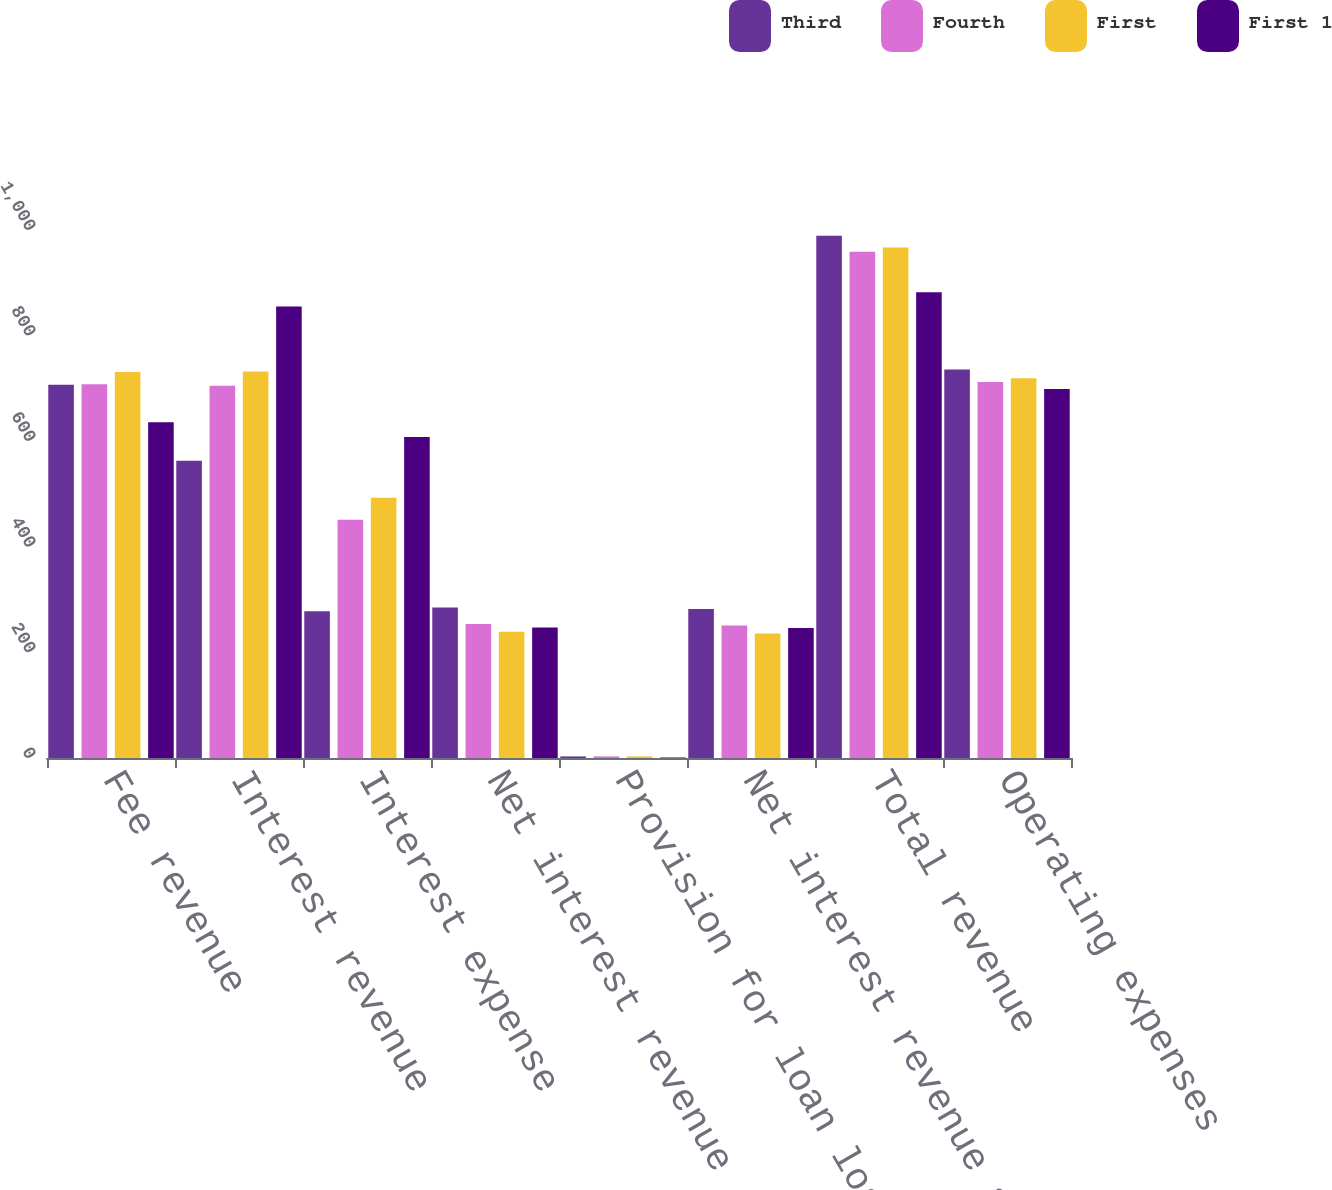<chart> <loc_0><loc_0><loc_500><loc_500><stacked_bar_chart><ecel><fcel>Fee revenue<fcel>Interest revenue<fcel>Interest expense<fcel>Net interest revenue<fcel>Provision for loan losses<fcel>Net interest revenue after<fcel>Total revenue<fcel>Operating expenses<nl><fcel>Third<fcel>707<fcel>563<fcel>278<fcel>285<fcel>3<fcel>282<fcel>989<fcel>736<nl><fcel>Fourth<fcel>708<fcel>705<fcel>451<fcel>254<fcel>3<fcel>251<fcel>959<fcel>712<nl><fcel>First<fcel>731<fcel>732<fcel>493<fcel>239<fcel>3<fcel>236<fcel>967<fcel>719<nl><fcel>First 1<fcel>636<fcel>855<fcel>608<fcel>247<fcel>1<fcel>246<fcel>882<fcel>699<nl></chart> 